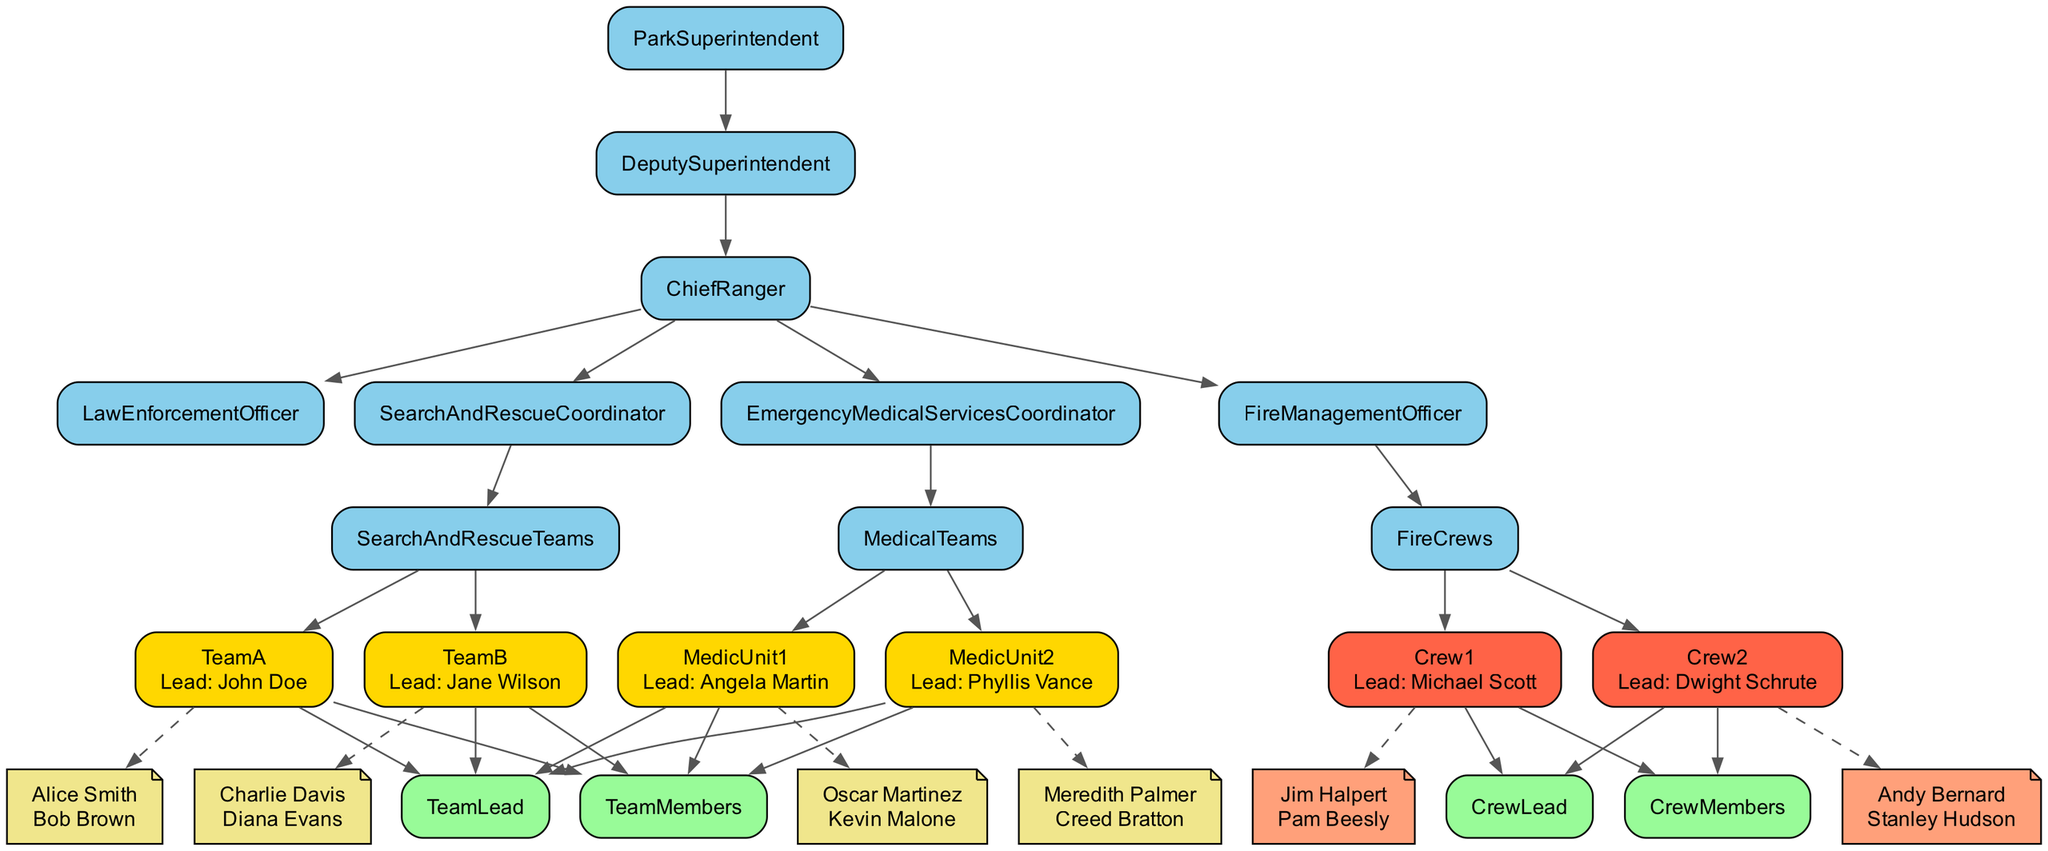What is the title of the highest position in the emergency response hierarchy? The highest position in the hierarchy is the Park Superintendent. This information can be easily identified as it is the top node in the diagram.
Answer: Park Superintendent Who is the team lead for Team A? The team lead for Team A is John Doe. This can be determined by looking at the details provided under the Search and Rescue Teams section for Team A.
Answer: John Doe How many team members are there in the Fire Management Officer's Crew 2? Crew 2 has two team members: Andy Bernard and Stanley Hudson. This can be seen by examining the Crew 2 section under Fire Management Officer and counting the listed members.
Answer: 2 Which unit does the Emergency Medical Services Coordinator oversee? The Emergency Medical Services Coordinator oversees Medical Teams. This is directly indicated in the hierarchy under the Emergency Medical Services Coordinator where Medical Teams are listed as a sub-division.
Answer: Medical Teams Who reports directly under the Chief Ranger? Directly under the Chief Ranger are the Law Enforcement Officer, Search and Rescue Coordinator, and Fire Management Officer. Each of these titles is listed as nodes stemming from the Chief Ranger.
Answer: Law Enforcement Officer, Search and Rescue Coordinator, Fire Management Officer What color is used to represent team leaders in the diagram? Team leaders are represented by a gold color. This is evident from the node styles specified in the diagram code, where the fill color for nodes containing team leaders is set to gold.
Answer: Gold Which medic unit has Angela Martin as the team lead? Medic Unit 1 has Angela Martin as the team lead. This can be found in the structure under Medical Teams, specifically within Medic Unit 1’s details.
Answer: Medic Unit 1 How many emergency response teams are under the Deputy Superintendent? There are three main emergency response teams under the Deputy Superintendent: Chief Ranger, Law Enforcement Officer, and Fire Management Officer. This number is obtained by counting the nodes that branch directly from the Deputy Superintendent.
Answer: 3 What type of teams does the Fire Management Officer manage? The Fire Management Officer manages Fire Crews. This is indicated in the hierarchy under the Fire Management Officer node, which directly leads to the Fire Crews section.
Answer: Fire Crews 